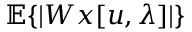Convert formula to latex. <formula><loc_0><loc_0><loc_500><loc_500>{ \mathbb { E } } \{ | W x [ u , \lambda ] | \}</formula> 